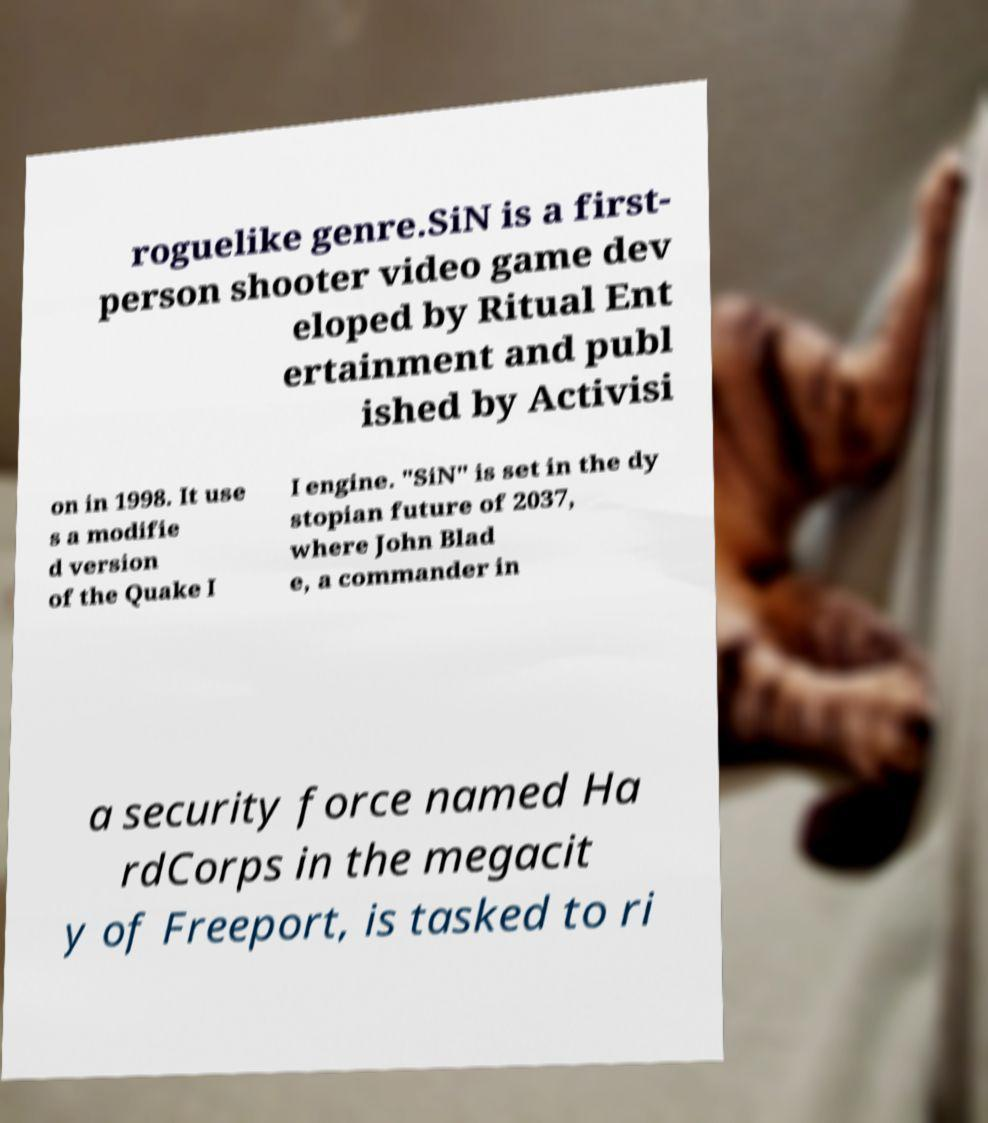Can you read and provide the text displayed in the image?This photo seems to have some interesting text. Can you extract and type it out for me? roguelike genre.SiN is a first- person shooter video game dev eloped by Ritual Ent ertainment and publ ished by Activisi on in 1998. It use s a modifie d version of the Quake I I engine. "SiN" is set in the dy stopian future of 2037, where John Blad e, a commander in a security force named Ha rdCorps in the megacit y of Freeport, is tasked to ri 